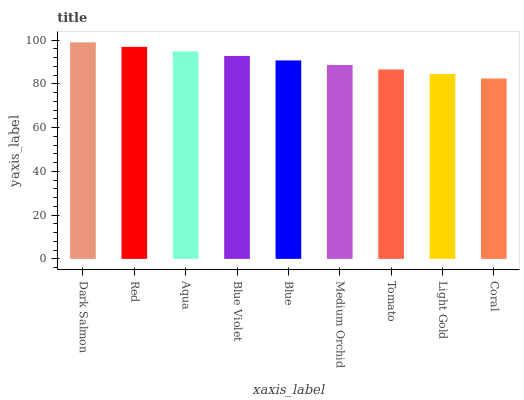Is Coral the minimum?
Answer yes or no. Yes. Is Dark Salmon the maximum?
Answer yes or no. Yes. Is Red the minimum?
Answer yes or no. No. Is Red the maximum?
Answer yes or no. No. Is Dark Salmon greater than Red?
Answer yes or no. Yes. Is Red less than Dark Salmon?
Answer yes or no. Yes. Is Red greater than Dark Salmon?
Answer yes or no. No. Is Dark Salmon less than Red?
Answer yes or no. No. Is Blue the high median?
Answer yes or no. Yes. Is Blue the low median?
Answer yes or no. Yes. Is Red the high median?
Answer yes or no. No. Is Aqua the low median?
Answer yes or no. No. 